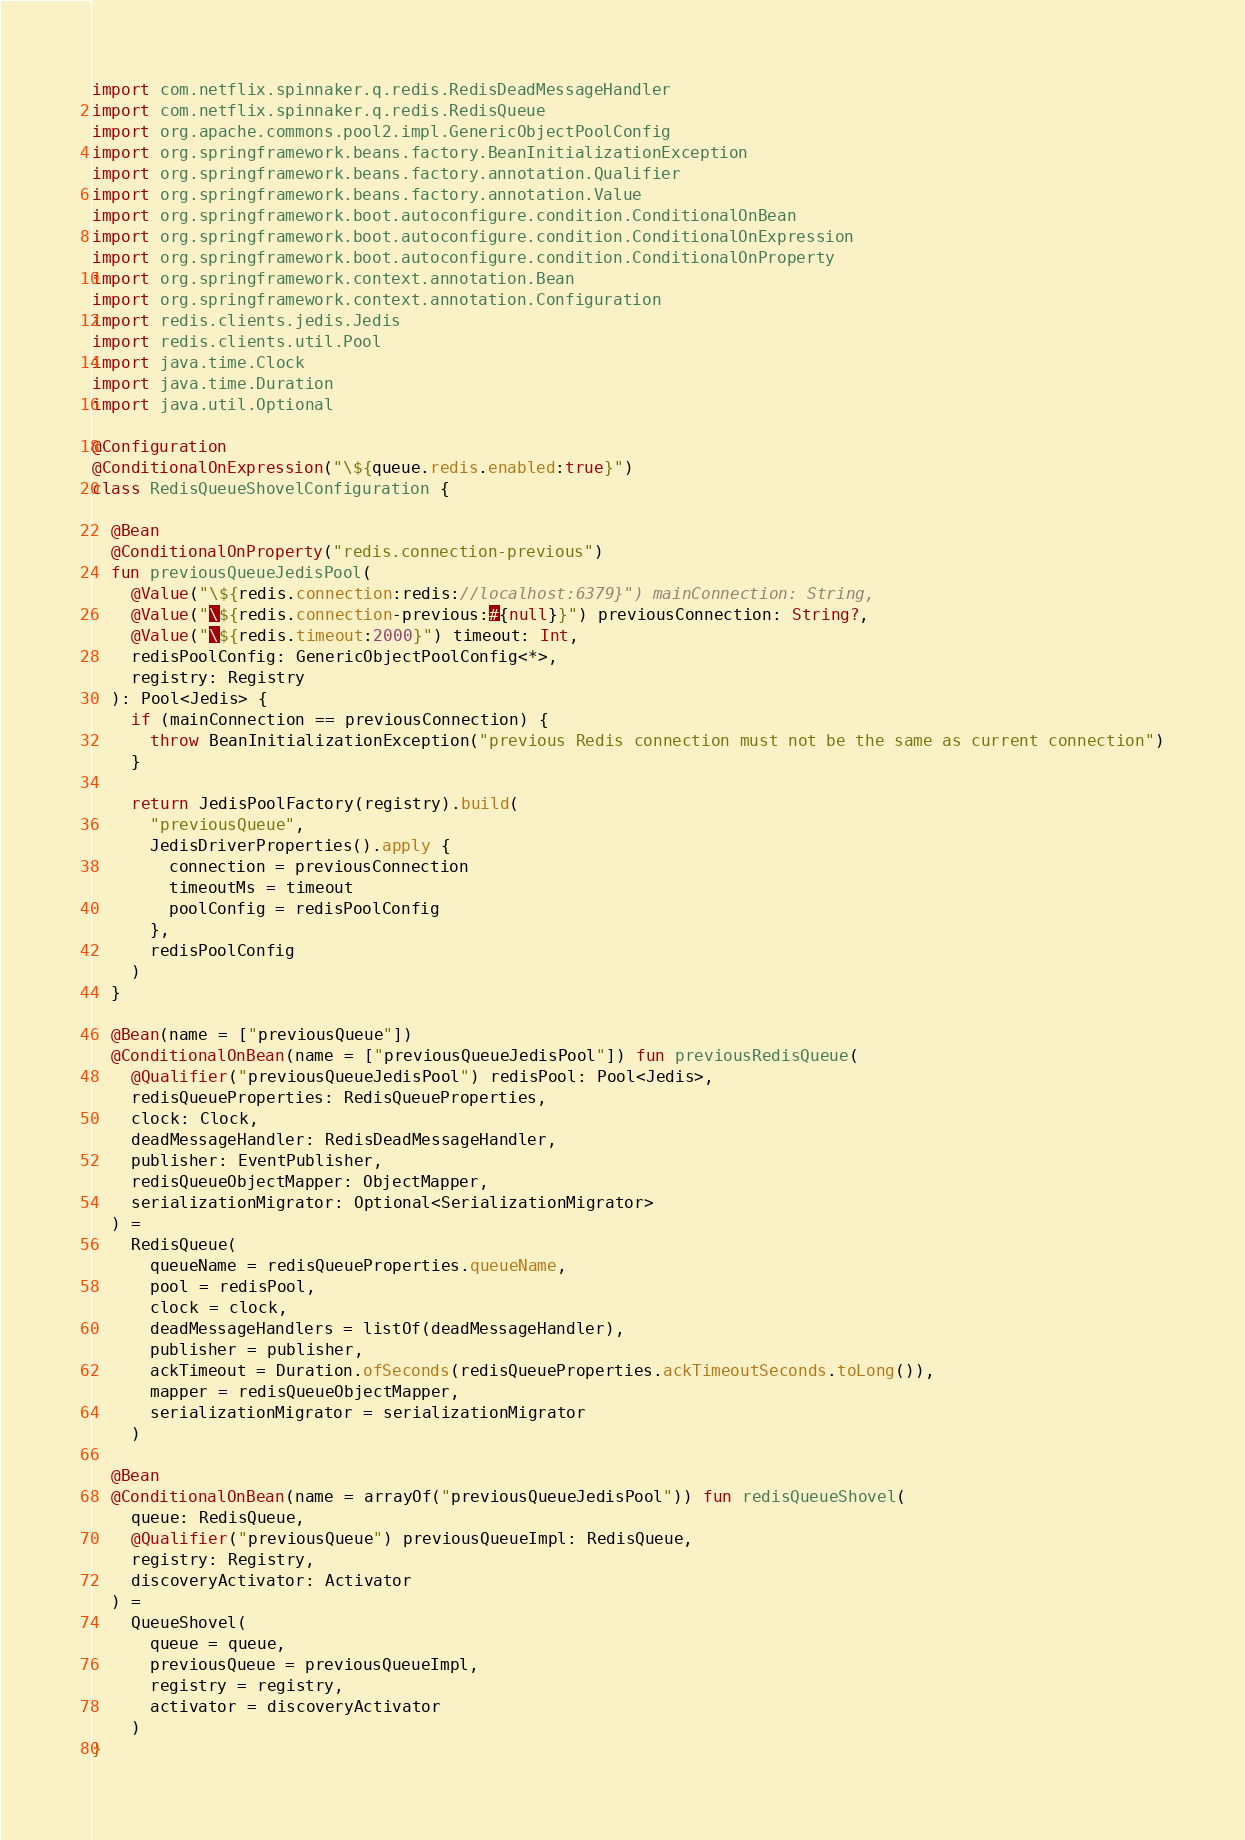<code> <loc_0><loc_0><loc_500><loc_500><_Kotlin_>import com.netflix.spinnaker.q.redis.RedisDeadMessageHandler
import com.netflix.spinnaker.q.redis.RedisQueue
import org.apache.commons.pool2.impl.GenericObjectPoolConfig
import org.springframework.beans.factory.BeanInitializationException
import org.springframework.beans.factory.annotation.Qualifier
import org.springframework.beans.factory.annotation.Value
import org.springframework.boot.autoconfigure.condition.ConditionalOnBean
import org.springframework.boot.autoconfigure.condition.ConditionalOnExpression
import org.springframework.boot.autoconfigure.condition.ConditionalOnProperty
import org.springframework.context.annotation.Bean
import org.springframework.context.annotation.Configuration
import redis.clients.jedis.Jedis
import redis.clients.util.Pool
import java.time.Clock
import java.time.Duration
import java.util.Optional

@Configuration
@ConditionalOnExpression("\${queue.redis.enabled:true}")
class RedisQueueShovelConfiguration {

  @Bean
  @ConditionalOnProperty("redis.connection-previous")
  fun previousQueueJedisPool(
    @Value("\${redis.connection:redis://localhost:6379}") mainConnection: String,
    @Value("\${redis.connection-previous:#{null}}") previousConnection: String?,
    @Value("\${redis.timeout:2000}") timeout: Int,
    redisPoolConfig: GenericObjectPoolConfig<*>,
    registry: Registry
  ): Pool<Jedis> {
    if (mainConnection == previousConnection) {
      throw BeanInitializationException("previous Redis connection must not be the same as current connection")
    }

    return JedisPoolFactory(registry).build(
      "previousQueue",
      JedisDriverProperties().apply {
        connection = previousConnection
        timeoutMs = timeout
        poolConfig = redisPoolConfig
      },
      redisPoolConfig
    )
  }

  @Bean(name = ["previousQueue"])
  @ConditionalOnBean(name = ["previousQueueJedisPool"]) fun previousRedisQueue(
    @Qualifier("previousQueueJedisPool") redisPool: Pool<Jedis>,
    redisQueueProperties: RedisQueueProperties,
    clock: Clock,
    deadMessageHandler: RedisDeadMessageHandler,
    publisher: EventPublisher,
    redisQueueObjectMapper: ObjectMapper,
    serializationMigrator: Optional<SerializationMigrator>
  ) =
    RedisQueue(
      queueName = redisQueueProperties.queueName,
      pool = redisPool,
      clock = clock,
      deadMessageHandlers = listOf(deadMessageHandler),
      publisher = publisher,
      ackTimeout = Duration.ofSeconds(redisQueueProperties.ackTimeoutSeconds.toLong()),
      mapper = redisQueueObjectMapper,
      serializationMigrator = serializationMigrator
    )

  @Bean
  @ConditionalOnBean(name = arrayOf("previousQueueJedisPool")) fun redisQueueShovel(
    queue: RedisQueue,
    @Qualifier("previousQueue") previousQueueImpl: RedisQueue,
    registry: Registry,
    discoveryActivator: Activator
  ) =
    QueueShovel(
      queue = queue,
      previousQueue = previousQueueImpl,
      registry = registry,
      activator = discoveryActivator
    )
}
</code> 